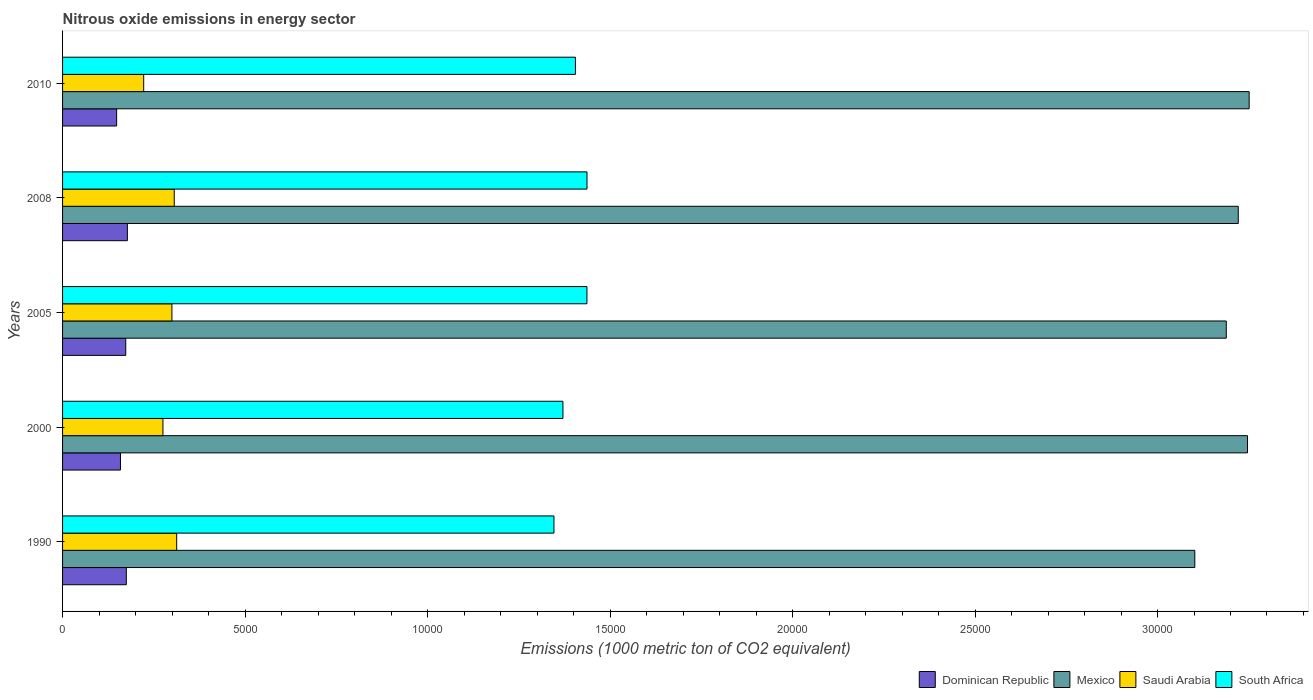How many different coloured bars are there?
Your response must be concise. 4. Are the number of bars on each tick of the Y-axis equal?
Your answer should be compact. Yes. How many bars are there on the 2nd tick from the top?
Offer a terse response. 4. How many bars are there on the 2nd tick from the bottom?
Provide a short and direct response. 4. What is the label of the 5th group of bars from the top?
Offer a very short reply. 1990. In how many cases, is the number of bars for a given year not equal to the number of legend labels?
Provide a succinct answer. 0. What is the amount of nitrous oxide emitted in Saudi Arabia in 2005?
Your answer should be very brief. 2996.3. Across all years, what is the maximum amount of nitrous oxide emitted in Dominican Republic?
Offer a very short reply. 1775.7. Across all years, what is the minimum amount of nitrous oxide emitted in Dominican Republic?
Provide a short and direct response. 1481.5. What is the total amount of nitrous oxide emitted in Saudi Arabia in the graph?
Make the answer very short. 1.42e+04. What is the difference between the amount of nitrous oxide emitted in Mexico in 2000 and that in 2005?
Ensure brevity in your answer.  581.7. What is the difference between the amount of nitrous oxide emitted in Saudi Arabia in 2005 and the amount of nitrous oxide emitted in Dominican Republic in 2008?
Provide a short and direct response. 1220.6. What is the average amount of nitrous oxide emitted in Saudi Arabia per year?
Ensure brevity in your answer.  2831.16. In the year 2008, what is the difference between the amount of nitrous oxide emitted in South Africa and amount of nitrous oxide emitted in Saudi Arabia?
Ensure brevity in your answer.  1.13e+04. What is the ratio of the amount of nitrous oxide emitted in Mexico in 2008 to that in 2010?
Offer a very short reply. 0.99. Is the amount of nitrous oxide emitted in South Africa in 2000 less than that in 2005?
Ensure brevity in your answer.  Yes. What is the difference between the highest and the second highest amount of nitrous oxide emitted in Mexico?
Your response must be concise. 45.2. What is the difference between the highest and the lowest amount of nitrous oxide emitted in Dominican Republic?
Provide a succinct answer. 294.2. Is it the case that in every year, the sum of the amount of nitrous oxide emitted in South Africa and amount of nitrous oxide emitted in Saudi Arabia is greater than the sum of amount of nitrous oxide emitted in Dominican Republic and amount of nitrous oxide emitted in Mexico?
Give a very brief answer. Yes. What does the 2nd bar from the top in 2005 represents?
Offer a very short reply. Saudi Arabia. What does the 3rd bar from the bottom in 2008 represents?
Offer a terse response. Saudi Arabia. How many years are there in the graph?
Ensure brevity in your answer.  5. What is the difference between two consecutive major ticks on the X-axis?
Make the answer very short. 5000. Are the values on the major ticks of X-axis written in scientific E-notation?
Provide a short and direct response. No. Does the graph contain any zero values?
Make the answer very short. No. Does the graph contain grids?
Make the answer very short. No. Where does the legend appear in the graph?
Offer a terse response. Bottom right. How are the legend labels stacked?
Provide a short and direct response. Horizontal. What is the title of the graph?
Your response must be concise. Nitrous oxide emissions in energy sector. Does "Yemen, Rep." appear as one of the legend labels in the graph?
Provide a short and direct response. No. What is the label or title of the X-axis?
Offer a very short reply. Emissions (1000 metric ton of CO2 equivalent). What is the Emissions (1000 metric ton of CO2 equivalent) of Dominican Republic in 1990?
Keep it short and to the point. 1746.5. What is the Emissions (1000 metric ton of CO2 equivalent) in Mexico in 1990?
Your response must be concise. 3.10e+04. What is the Emissions (1000 metric ton of CO2 equivalent) of Saudi Arabia in 1990?
Your response must be concise. 3126.9. What is the Emissions (1000 metric ton of CO2 equivalent) in South Africa in 1990?
Your response must be concise. 1.35e+04. What is the Emissions (1000 metric ton of CO2 equivalent) in Dominican Republic in 2000?
Ensure brevity in your answer.  1586.4. What is the Emissions (1000 metric ton of CO2 equivalent) of Mexico in 2000?
Provide a short and direct response. 3.25e+04. What is the Emissions (1000 metric ton of CO2 equivalent) in Saudi Arabia in 2000?
Your answer should be very brief. 2750.6. What is the Emissions (1000 metric ton of CO2 equivalent) in South Africa in 2000?
Give a very brief answer. 1.37e+04. What is the Emissions (1000 metric ton of CO2 equivalent) in Dominican Republic in 2005?
Offer a terse response. 1731. What is the Emissions (1000 metric ton of CO2 equivalent) in Mexico in 2005?
Provide a short and direct response. 3.19e+04. What is the Emissions (1000 metric ton of CO2 equivalent) in Saudi Arabia in 2005?
Provide a succinct answer. 2996.3. What is the Emissions (1000 metric ton of CO2 equivalent) of South Africa in 2005?
Give a very brief answer. 1.44e+04. What is the Emissions (1000 metric ton of CO2 equivalent) in Dominican Republic in 2008?
Offer a terse response. 1775.7. What is the Emissions (1000 metric ton of CO2 equivalent) of Mexico in 2008?
Your answer should be compact. 3.22e+04. What is the Emissions (1000 metric ton of CO2 equivalent) in Saudi Arabia in 2008?
Offer a terse response. 3059.4. What is the Emissions (1000 metric ton of CO2 equivalent) in South Africa in 2008?
Provide a short and direct response. 1.44e+04. What is the Emissions (1000 metric ton of CO2 equivalent) of Dominican Republic in 2010?
Your response must be concise. 1481.5. What is the Emissions (1000 metric ton of CO2 equivalent) in Mexico in 2010?
Offer a very short reply. 3.25e+04. What is the Emissions (1000 metric ton of CO2 equivalent) of Saudi Arabia in 2010?
Offer a very short reply. 2222.6. What is the Emissions (1000 metric ton of CO2 equivalent) in South Africa in 2010?
Offer a terse response. 1.41e+04. Across all years, what is the maximum Emissions (1000 metric ton of CO2 equivalent) of Dominican Republic?
Your answer should be compact. 1775.7. Across all years, what is the maximum Emissions (1000 metric ton of CO2 equivalent) of Mexico?
Your response must be concise. 3.25e+04. Across all years, what is the maximum Emissions (1000 metric ton of CO2 equivalent) of Saudi Arabia?
Give a very brief answer. 3126.9. Across all years, what is the maximum Emissions (1000 metric ton of CO2 equivalent) in South Africa?
Keep it short and to the point. 1.44e+04. Across all years, what is the minimum Emissions (1000 metric ton of CO2 equivalent) in Dominican Republic?
Give a very brief answer. 1481.5. Across all years, what is the minimum Emissions (1000 metric ton of CO2 equivalent) in Mexico?
Give a very brief answer. 3.10e+04. Across all years, what is the minimum Emissions (1000 metric ton of CO2 equivalent) of Saudi Arabia?
Offer a terse response. 2222.6. Across all years, what is the minimum Emissions (1000 metric ton of CO2 equivalent) of South Africa?
Keep it short and to the point. 1.35e+04. What is the total Emissions (1000 metric ton of CO2 equivalent) in Dominican Republic in the graph?
Keep it short and to the point. 8321.1. What is the total Emissions (1000 metric ton of CO2 equivalent) in Mexico in the graph?
Ensure brevity in your answer.  1.60e+05. What is the total Emissions (1000 metric ton of CO2 equivalent) in Saudi Arabia in the graph?
Provide a succinct answer. 1.42e+04. What is the total Emissions (1000 metric ton of CO2 equivalent) in South Africa in the graph?
Ensure brevity in your answer.  7.00e+04. What is the difference between the Emissions (1000 metric ton of CO2 equivalent) in Dominican Republic in 1990 and that in 2000?
Ensure brevity in your answer.  160.1. What is the difference between the Emissions (1000 metric ton of CO2 equivalent) of Mexico in 1990 and that in 2000?
Provide a short and direct response. -1444. What is the difference between the Emissions (1000 metric ton of CO2 equivalent) in Saudi Arabia in 1990 and that in 2000?
Make the answer very short. 376.3. What is the difference between the Emissions (1000 metric ton of CO2 equivalent) in South Africa in 1990 and that in 2000?
Give a very brief answer. -246.5. What is the difference between the Emissions (1000 metric ton of CO2 equivalent) in Mexico in 1990 and that in 2005?
Keep it short and to the point. -862.3. What is the difference between the Emissions (1000 metric ton of CO2 equivalent) in Saudi Arabia in 1990 and that in 2005?
Give a very brief answer. 130.6. What is the difference between the Emissions (1000 metric ton of CO2 equivalent) in South Africa in 1990 and that in 2005?
Provide a succinct answer. -903.7. What is the difference between the Emissions (1000 metric ton of CO2 equivalent) of Dominican Republic in 1990 and that in 2008?
Offer a very short reply. -29.2. What is the difference between the Emissions (1000 metric ton of CO2 equivalent) of Mexico in 1990 and that in 2008?
Make the answer very short. -1190.5. What is the difference between the Emissions (1000 metric ton of CO2 equivalent) in Saudi Arabia in 1990 and that in 2008?
Offer a terse response. 67.5. What is the difference between the Emissions (1000 metric ton of CO2 equivalent) in South Africa in 1990 and that in 2008?
Your answer should be compact. -905.7. What is the difference between the Emissions (1000 metric ton of CO2 equivalent) in Dominican Republic in 1990 and that in 2010?
Your answer should be compact. 265. What is the difference between the Emissions (1000 metric ton of CO2 equivalent) of Mexico in 1990 and that in 2010?
Your answer should be compact. -1489.2. What is the difference between the Emissions (1000 metric ton of CO2 equivalent) of Saudi Arabia in 1990 and that in 2010?
Offer a very short reply. 904.3. What is the difference between the Emissions (1000 metric ton of CO2 equivalent) in South Africa in 1990 and that in 2010?
Offer a very short reply. -588.2. What is the difference between the Emissions (1000 metric ton of CO2 equivalent) of Dominican Republic in 2000 and that in 2005?
Provide a short and direct response. -144.6. What is the difference between the Emissions (1000 metric ton of CO2 equivalent) of Mexico in 2000 and that in 2005?
Give a very brief answer. 581.7. What is the difference between the Emissions (1000 metric ton of CO2 equivalent) of Saudi Arabia in 2000 and that in 2005?
Offer a terse response. -245.7. What is the difference between the Emissions (1000 metric ton of CO2 equivalent) of South Africa in 2000 and that in 2005?
Your answer should be compact. -657.2. What is the difference between the Emissions (1000 metric ton of CO2 equivalent) in Dominican Republic in 2000 and that in 2008?
Give a very brief answer. -189.3. What is the difference between the Emissions (1000 metric ton of CO2 equivalent) in Mexico in 2000 and that in 2008?
Ensure brevity in your answer.  253.5. What is the difference between the Emissions (1000 metric ton of CO2 equivalent) of Saudi Arabia in 2000 and that in 2008?
Provide a short and direct response. -308.8. What is the difference between the Emissions (1000 metric ton of CO2 equivalent) of South Africa in 2000 and that in 2008?
Keep it short and to the point. -659.2. What is the difference between the Emissions (1000 metric ton of CO2 equivalent) in Dominican Republic in 2000 and that in 2010?
Provide a short and direct response. 104.9. What is the difference between the Emissions (1000 metric ton of CO2 equivalent) of Mexico in 2000 and that in 2010?
Provide a short and direct response. -45.2. What is the difference between the Emissions (1000 metric ton of CO2 equivalent) of Saudi Arabia in 2000 and that in 2010?
Make the answer very short. 528. What is the difference between the Emissions (1000 metric ton of CO2 equivalent) of South Africa in 2000 and that in 2010?
Keep it short and to the point. -341.7. What is the difference between the Emissions (1000 metric ton of CO2 equivalent) of Dominican Republic in 2005 and that in 2008?
Offer a very short reply. -44.7. What is the difference between the Emissions (1000 metric ton of CO2 equivalent) in Mexico in 2005 and that in 2008?
Offer a terse response. -328.2. What is the difference between the Emissions (1000 metric ton of CO2 equivalent) in Saudi Arabia in 2005 and that in 2008?
Provide a succinct answer. -63.1. What is the difference between the Emissions (1000 metric ton of CO2 equivalent) of South Africa in 2005 and that in 2008?
Ensure brevity in your answer.  -2. What is the difference between the Emissions (1000 metric ton of CO2 equivalent) in Dominican Republic in 2005 and that in 2010?
Your answer should be very brief. 249.5. What is the difference between the Emissions (1000 metric ton of CO2 equivalent) in Mexico in 2005 and that in 2010?
Ensure brevity in your answer.  -626.9. What is the difference between the Emissions (1000 metric ton of CO2 equivalent) of Saudi Arabia in 2005 and that in 2010?
Your answer should be very brief. 773.7. What is the difference between the Emissions (1000 metric ton of CO2 equivalent) in South Africa in 2005 and that in 2010?
Make the answer very short. 315.5. What is the difference between the Emissions (1000 metric ton of CO2 equivalent) in Dominican Republic in 2008 and that in 2010?
Your answer should be compact. 294.2. What is the difference between the Emissions (1000 metric ton of CO2 equivalent) of Mexico in 2008 and that in 2010?
Provide a succinct answer. -298.7. What is the difference between the Emissions (1000 metric ton of CO2 equivalent) in Saudi Arabia in 2008 and that in 2010?
Your answer should be compact. 836.8. What is the difference between the Emissions (1000 metric ton of CO2 equivalent) in South Africa in 2008 and that in 2010?
Make the answer very short. 317.5. What is the difference between the Emissions (1000 metric ton of CO2 equivalent) of Dominican Republic in 1990 and the Emissions (1000 metric ton of CO2 equivalent) of Mexico in 2000?
Keep it short and to the point. -3.07e+04. What is the difference between the Emissions (1000 metric ton of CO2 equivalent) in Dominican Republic in 1990 and the Emissions (1000 metric ton of CO2 equivalent) in Saudi Arabia in 2000?
Your response must be concise. -1004.1. What is the difference between the Emissions (1000 metric ton of CO2 equivalent) of Dominican Republic in 1990 and the Emissions (1000 metric ton of CO2 equivalent) of South Africa in 2000?
Make the answer very short. -1.20e+04. What is the difference between the Emissions (1000 metric ton of CO2 equivalent) in Mexico in 1990 and the Emissions (1000 metric ton of CO2 equivalent) in Saudi Arabia in 2000?
Offer a very short reply. 2.83e+04. What is the difference between the Emissions (1000 metric ton of CO2 equivalent) of Mexico in 1990 and the Emissions (1000 metric ton of CO2 equivalent) of South Africa in 2000?
Ensure brevity in your answer.  1.73e+04. What is the difference between the Emissions (1000 metric ton of CO2 equivalent) of Saudi Arabia in 1990 and the Emissions (1000 metric ton of CO2 equivalent) of South Africa in 2000?
Offer a terse response. -1.06e+04. What is the difference between the Emissions (1000 metric ton of CO2 equivalent) of Dominican Republic in 1990 and the Emissions (1000 metric ton of CO2 equivalent) of Mexico in 2005?
Provide a succinct answer. -3.01e+04. What is the difference between the Emissions (1000 metric ton of CO2 equivalent) of Dominican Republic in 1990 and the Emissions (1000 metric ton of CO2 equivalent) of Saudi Arabia in 2005?
Your response must be concise. -1249.8. What is the difference between the Emissions (1000 metric ton of CO2 equivalent) in Dominican Republic in 1990 and the Emissions (1000 metric ton of CO2 equivalent) in South Africa in 2005?
Your answer should be very brief. -1.26e+04. What is the difference between the Emissions (1000 metric ton of CO2 equivalent) in Mexico in 1990 and the Emissions (1000 metric ton of CO2 equivalent) in Saudi Arabia in 2005?
Ensure brevity in your answer.  2.80e+04. What is the difference between the Emissions (1000 metric ton of CO2 equivalent) in Mexico in 1990 and the Emissions (1000 metric ton of CO2 equivalent) in South Africa in 2005?
Your answer should be very brief. 1.67e+04. What is the difference between the Emissions (1000 metric ton of CO2 equivalent) in Saudi Arabia in 1990 and the Emissions (1000 metric ton of CO2 equivalent) in South Africa in 2005?
Keep it short and to the point. -1.12e+04. What is the difference between the Emissions (1000 metric ton of CO2 equivalent) of Dominican Republic in 1990 and the Emissions (1000 metric ton of CO2 equivalent) of Mexico in 2008?
Offer a very short reply. -3.05e+04. What is the difference between the Emissions (1000 metric ton of CO2 equivalent) of Dominican Republic in 1990 and the Emissions (1000 metric ton of CO2 equivalent) of Saudi Arabia in 2008?
Your answer should be compact. -1312.9. What is the difference between the Emissions (1000 metric ton of CO2 equivalent) of Dominican Republic in 1990 and the Emissions (1000 metric ton of CO2 equivalent) of South Africa in 2008?
Ensure brevity in your answer.  -1.26e+04. What is the difference between the Emissions (1000 metric ton of CO2 equivalent) in Mexico in 1990 and the Emissions (1000 metric ton of CO2 equivalent) in Saudi Arabia in 2008?
Your answer should be very brief. 2.80e+04. What is the difference between the Emissions (1000 metric ton of CO2 equivalent) in Mexico in 1990 and the Emissions (1000 metric ton of CO2 equivalent) in South Africa in 2008?
Ensure brevity in your answer.  1.67e+04. What is the difference between the Emissions (1000 metric ton of CO2 equivalent) of Saudi Arabia in 1990 and the Emissions (1000 metric ton of CO2 equivalent) of South Africa in 2008?
Provide a short and direct response. -1.12e+04. What is the difference between the Emissions (1000 metric ton of CO2 equivalent) in Dominican Republic in 1990 and the Emissions (1000 metric ton of CO2 equivalent) in Mexico in 2010?
Give a very brief answer. -3.08e+04. What is the difference between the Emissions (1000 metric ton of CO2 equivalent) of Dominican Republic in 1990 and the Emissions (1000 metric ton of CO2 equivalent) of Saudi Arabia in 2010?
Your answer should be very brief. -476.1. What is the difference between the Emissions (1000 metric ton of CO2 equivalent) in Dominican Republic in 1990 and the Emissions (1000 metric ton of CO2 equivalent) in South Africa in 2010?
Your answer should be compact. -1.23e+04. What is the difference between the Emissions (1000 metric ton of CO2 equivalent) in Mexico in 1990 and the Emissions (1000 metric ton of CO2 equivalent) in Saudi Arabia in 2010?
Your answer should be very brief. 2.88e+04. What is the difference between the Emissions (1000 metric ton of CO2 equivalent) of Mexico in 1990 and the Emissions (1000 metric ton of CO2 equivalent) of South Africa in 2010?
Make the answer very short. 1.70e+04. What is the difference between the Emissions (1000 metric ton of CO2 equivalent) of Saudi Arabia in 1990 and the Emissions (1000 metric ton of CO2 equivalent) of South Africa in 2010?
Offer a terse response. -1.09e+04. What is the difference between the Emissions (1000 metric ton of CO2 equivalent) in Dominican Republic in 2000 and the Emissions (1000 metric ton of CO2 equivalent) in Mexico in 2005?
Your answer should be compact. -3.03e+04. What is the difference between the Emissions (1000 metric ton of CO2 equivalent) of Dominican Republic in 2000 and the Emissions (1000 metric ton of CO2 equivalent) of Saudi Arabia in 2005?
Keep it short and to the point. -1409.9. What is the difference between the Emissions (1000 metric ton of CO2 equivalent) in Dominican Republic in 2000 and the Emissions (1000 metric ton of CO2 equivalent) in South Africa in 2005?
Your answer should be compact. -1.28e+04. What is the difference between the Emissions (1000 metric ton of CO2 equivalent) of Mexico in 2000 and the Emissions (1000 metric ton of CO2 equivalent) of Saudi Arabia in 2005?
Make the answer very short. 2.95e+04. What is the difference between the Emissions (1000 metric ton of CO2 equivalent) in Mexico in 2000 and the Emissions (1000 metric ton of CO2 equivalent) in South Africa in 2005?
Ensure brevity in your answer.  1.81e+04. What is the difference between the Emissions (1000 metric ton of CO2 equivalent) in Saudi Arabia in 2000 and the Emissions (1000 metric ton of CO2 equivalent) in South Africa in 2005?
Keep it short and to the point. -1.16e+04. What is the difference between the Emissions (1000 metric ton of CO2 equivalent) in Dominican Republic in 2000 and the Emissions (1000 metric ton of CO2 equivalent) in Mexico in 2008?
Ensure brevity in your answer.  -3.06e+04. What is the difference between the Emissions (1000 metric ton of CO2 equivalent) in Dominican Republic in 2000 and the Emissions (1000 metric ton of CO2 equivalent) in Saudi Arabia in 2008?
Your response must be concise. -1473. What is the difference between the Emissions (1000 metric ton of CO2 equivalent) of Dominican Republic in 2000 and the Emissions (1000 metric ton of CO2 equivalent) of South Africa in 2008?
Provide a succinct answer. -1.28e+04. What is the difference between the Emissions (1000 metric ton of CO2 equivalent) in Mexico in 2000 and the Emissions (1000 metric ton of CO2 equivalent) in Saudi Arabia in 2008?
Make the answer very short. 2.94e+04. What is the difference between the Emissions (1000 metric ton of CO2 equivalent) of Mexico in 2000 and the Emissions (1000 metric ton of CO2 equivalent) of South Africa in 2008?
Your response must be concise. 1.81e+04. What is the difference between the Emissions (1000 metric ton of CO2 equivalent) of Saudi Arabia in 2000 and the Emissions (1000 metric ton of CO2 equivalent) of South Africa in 2008?
Give a very brief answer. -1.16e+04. What is the difference between the Emissions (1000 metric ton of CO2 equivalent) of Dominican Republic in 2000 and the Emissions (1000 metric ton of CO2 equivalent) of Mexico in 2010?
Ensure brevity in your answer.  -3.09e+04. What is the difference between the Emissions (1000 metric ton of CO2 equivalent) in Dominican Republic in 2000 and the Emissions (1000 metric ton of CO2 equivalent) in Saudi Arabia in 2010?
Keep it short and to the point. -636.2. What is the difference between the Emissions (1000 metric ton of CO2 equivalent) in Dominican Republic in 2000 and the Emissions (1000 metric ton of CO2 equivalent) in South Africa in 2010?
Offer a terse response. -1.25e+04. What is the difference between the Emissions (1000 metric ton of CO2 equivalent) in Mexico in 2000 and the Emissions (1000 metric ton of CO2 equivalent) in Saudi Arabia in 2010?
Give a very brief answer. 3.02e+04. What is the difference between the Emissions (1000 metric ton of CO2 equivalent) of Mexico in 2000 and the Emissions (1000 metric ton of CO2 equivalent) of South Africa in 2010?
Provide a succinct answer. 1.84e+04. What is the difference between the Emissions (1000 metric ton of CO2 equivalent) of Saudi Arabia in 2000 and the Emissions (1000 metric ton of CO2 equivalent) of South Africa in 2010?
Your response must be concise. -1.13e+04. What is the difference between the Emissions (1000 metric ton of CO2 equivalent) in Dominican Republic in 2005 and the Emissions (1000 metric ton of CO2 equivalent) in Mexico in 2008?
Your answer should be very brief. -3.05e+04. What is the difference between the Emissions (1000 metric ton of CO2 equivalent) of Dominican Republic in 2005 and the Emissions (1000 metric ton of CO2 equivalent) of Saudi Arabia in 2008?
Give a very brief answer. -1328.4. What is the difference between the Emissions (1000 metric ton of CO2 equivalent) in Dominican Republic in 2005 and the Emissions (1000 metric ton of CO2 equivalent) in South Africa in 2008?
Provide a succinct answer. -1.26e+04. What is the difference between the Emissions (1000 metric ton of CO2 equivalent) of Mexico in 2005 and the Emissions (1000 metric ton of CO2 equivalent) of Saudi Arabia in 2008?
Make the answer very short. 2.88e+04. What is the difference between the Emissions (1000 metric ton of CO2 equivalent) in Mexico in 2005 and the Emissions (1000 metric ton of CO2 equivalent) in South Africa in 2008?
Give a very brief answer. 1.75e+04. What is the difference between the Emissions (1000 metric ton of CO2 equivalent) of Saudi Arabia in 2005 and the Emissions (1000 metric ton of CO2 equivalent) of South Africa in 2008?
Your response must be concise. -1.14e+04. What is the difference between the Emissions (1000 metric ton of CO2 equivalent) in Dominican Republic in 2005 and the Emissions (1000 metric ton of CO2 equivalent) in Mexico in 2010?
Make the answer very short. -3.08e+04. What is the difference between the Emissions (1000 metric ton of CO2 equivalent) of Dominican Republic in 2005 and the Emissions (1000 metric ton of CO2 equivalent) of Saudi Arabia in 2010?
Offer a very short reply. -491.6. What is the difference between the Emissions (1000 metric ton of CO2 equivalent) in Dominican Republic in 2005 and the Emissions (1000 metric ton of CO2 equivalent) in South Africa in 2010?
Offer a terse response. -1.23e+04. What is the difference between the Emissions (1000 metric ton of CO2 equivalent) of Mexico in 2005 and the Emissions (1000 metric ton of CO2 equivalent) of Saudi Arabia in 2010?
Ensure brevity in your answer.  2.97e+04. What is the difference between the Emissions (1000 metric ton of CO2 equivalent) in Mexico in 2005 and the Emissions (1000 metric ton of CO2 equivalent) in South Africa in 2010?
Keep it short and to the point. 1.78e+04. What is the difference between the Emissions (1000 metric ton of CO2 equivalent) in Saudi Arabia in 2005 and the Emissions (1000 metric ton of CO2 equivalent) in South Africa in 2010?
Offer a terse response. -1.11e+04. What is the difference between the Emissions (1000 metric ton of CO2 equivalent) in Dominican Republic in 2008 and the Emissions (1000 metric ton of CO2 equivalent) in Mexico in 2010?
Give a very brief answer. -3.07e+04. What is the difference between the Emissions (1000 metric ton of CO2 equivalent) of Dominican Republic in 2008 and the Emissions (1000 metric ton of CO2 equivalent) of Saudi Arabia in 2010?
Provide a succinct answer. -446.9. What is the difference between the Emissions (1000 metric ton of CO2 equivalent) in Dominican Republic in 2008 and the Emissions (1000 metric ton of CO2 equivalent) in South Africa in 2010?
Your response must be concise. -1.23e+04. What is the difference between the Emissions (1000 metric ton of CO2 equivalent) in Mexico in 2008 and the Emissions (1000 metric ton of CO2 equivalent) in Saudi Arabia in 2010?
Offer a very short reply. 3.00e+04. What is the difference between the Emissions (1000 metric ton of CO2 equivalent) in Mexico in 2008 and the Emissions (1000 metric ton of CO2 equivalent) in South Africa in 2010?
Provide a succinct answer. 1.82e+04. What is the difference between the Emissions (1000 metric ton of CO2 equivalent) of Saudi Arabia in 2008 and the Emissions (1000 metric ton of CO2 equivalent) of South Africa in 2010?
Your response must be concise. -1.10e+04. What is the average Emissions (1000 metric ton of CO2 equivalent) of Dominican Republic per year?
Provide a short and direct response. 1664.22. What is the average Emissions (1000 metric ton of CO2 equivalent) in Mexico per year?
Offer a very short reply. 3.20e+04. What is the average Emissions (1000 metric ton of CO2 equivalent) of Saudi Arabia per year?
Your response must be concise. 2831.16. What is the average Emissions (1000 metric ton of CO2 equivalent) of South Africa per year?
Your answer should be very brief. 1.40e+04. In the year 1990, what is the difference between the Emissions (1000 metric ton of CO2 equivalent) of Dominican Republic and Emissions (1000 metric ton of CO2 equivalent) of Mexico?
Your answer should be very brief. -2.93e+04. In the year 1990, what is the difference between the Emissions (1000 metric ton of CO2 equivalent) of Dominican Republic and Emissions (1000 metric ton of CO2 equivalent) of Saudi Arabia?
Offer a very short reply. -1380.4. In the year 1990, what is the difference between the Emissions (1000 metric ton of CO2 equivalent) in Dominican Republic and Emissions (1000 metric ton of CO2 equivalent) in South Africa?
Offer a very short reply. -1.17e+04. In the year 1990, what is the difference between the Emissions (1000 metric ton of CO2 equivalent) in Mexico and Emissions (1000 metric ton of CO2 equivalent) in Saudi Arabia?
Ensure brevity in your answer.  2.79e+04. In the year 1990, what is the difference between the Emissions (1000 metric ton of CO2 equivalent) in Mexico and Emissions (1000 metric ton of CO2 equivalent) in South Africa?
Provide a succinct answer. 1.76e+04. In the year 1990, what is the difference between the Emissions (1000 metric ton of CO2 equivalent) in Saudi Arabia and Emissions (1000 metric ton of CO2 equivalent) in South Africa?
Make the answer very short. -1.03e+04. In the year 2000, what is the difference between the Emissions (1000 metric ton of CO2 equivalent) of Dominican Republic and Emissions (1000 metric ton of CO2 equivalent) of Mexico?
Provide a short and direct response. -3.09e+04. In the year 2000, what is the difference between the Emissions (1000 metric ton of CO2 equivalent) in Dominican Republic and Emissions (1000 metric ton of CO2 equivalent) in Saudi Arabia?
Your answer should be very brief. -1164.2. In the year 2000, what is the difference between the Emissions (1000 metric ton of CO2 equivalent) of Dominican Republic and Emissions (1000 metric ton of CO2 equivalent) of South Africa?
Make the answer very short. -1.21e+04. In the year 2000, what is the difference between the Emissions (1000 metric ton of CO2 equivalent) of Mexico and Emissions (1000 metric ton of CO2 equivalent) of Saudi Arabia?
Give a very brief answer. 2.97e+04. In the year 2000, what is the difference between the Emissions (1000 metric ton of CO2 equivalent) of Mexico and Emissions (1000 metric ton of CO2 equivalent) of South Africa?
Make the answer very short. 1.88e+04. In the year 2000, what is the difference between the Emissions (1000 metric ton of CO2 equivalent) of Saudi Arabia and Emissions (1000 metric ton of CO2 equivalent) of South Africa?
Make the answer very short. -1.10e+04. In the year 2005, what is the difference between the Emissions (1000 metric ton of CO2 equivalent) in Dominican Republic and Emissions (1000 metric ton of CO2 equivalent) in Mexico?
Provide a succinct answer. -3.02e+04. In the year 2005, what is the difference between the Emissions (1000 metric ton of CO2 equivalent) of Dominican Republic and Emissions (1000 metric ton of CO2 equivalent) of Saudi Arabia?
Your answer should be very brief. -1265.3. In the year 2005, what is the difference between the Emissions (1000 metric ton of CO2 equivalent) of Dominican Republic and Emissions (1000 metric ton of CO2 equivalent) of South Africa?
Your answer should be very brief. -1.26e+04. In the year 2005, what is the difference between the Emissions (1000 metric ton of CO2 equivalent) in Mexico and Emissions (1000 metric ton of CO2 equivalent) in Saudi Arabia?
Provide a short and direct response. 2.89e+04. In the year 2005, what is the difference between the Emissions (1000 metric ton of CO2 equivalent) in Mexico and Emissions (1000 metric ton of CO2 equivalent) in South Africa?
Keep it short and to the point. 1.75e+04. In the year 2005, what is the difference between the Emissions (1000 metric ton of CO2 equivalent) of Saudi Arabia and Emissions (1000 metric ton of CO2 equivalent) of South Africa?
Make the answer very short. -1.14e+04. In the year 2008, what is the difference between the Emissions (1000 metric ton of CO2 equivalent) in Dominican Republic and Emissions (1000 metric ton of CO2 equivalent) in Mexico?
Your response must be concise. -3.04e+04. In the year 2008, what is the difference between the Emissions (1000 metric ton of CO2 equivalent) in Dominican Republic and Emissions (1000 metric ton of CO2 equivalent) in Saudi Arabia?
Provide a short and direct response. -1283.7. In the year 2008, what is the difference between the Emissions (1000 metric ton of CO2 equivalent) of Dominican Republic and Emissions (1000 metric ton of CO2 equivalent) of South Africa?
Your answer should be compact. -1.26e+04. In the year 2008, what is the difference between the Emissions (1000 metric ton of CO2 equivalent) of Mexico and Emissions (1000 metric ton of CO2 equivalent) of Saudi Arabia?
Ensure brevity in your answer.  2.92e+04. In the year 2008, what is the difference between the Emissions (1000 metric ton of CO2 equivalent) of Mexico and Emissions (1000 metric ton of CO2 equivalent) of South Africa?
Your answer should be very brief. 1.78e+04. In the year 2008, what is the difference between the Emissions (1000 metric ton of CO2 equivalent) in Saudi Arabia and Emissions (1000 metric ton of CO2 equivalent) in South Africa?
Offer a terse response. -1.13e+04. In the year 2010, what is the difference between the Emissions (1000 metric ton of CO2 equivalent) of Dominican Republic and Emissions (1000 metric ton of CO2 equivalent) of Mexico?
Your response must be concise. -3.10e+04. In the year 2010, what is the difference between the Emissions (1000 metric ton of CO2 equivalent) of Dominican Republic and Emissions (1000 metric ton of CO2 equivalent) of Saudi Arabia?
Keep it short and to the point. -741.1. In the year 2010, what is the difference between the Emissions (1000 metric ton of CO2 equivalent) in Dominican Republic and Emissions (1000 metric ton of CO2 equivalent) in South Africa?
Make the answer very short. -1.26e+04. In the year 2010, what is the difference between the Emissions (1000 metric ton of CO2 equivalent) of Mexico and Emissions (1000 metric ton of CO2 equivalent) of Saudi Arabia?
Make the answer very short. 3.03e+04. In the year 2010, what is the difference between the Emissions (1000 metric ton of CO2 equivalent) in Mexico and Emissions (1000 metric ton of CO2 equivalent) in South Africa?
Offer a very short reply. 1.85e+04. In the year 2010, what is the difference between the Emissions (1000 metric ton of CO2 equivalent) in Saudi Arabia and Emissions (1000 metric ton of CO2 equivalent) in South Africa?
Make the answer very short. -1.18e+04. What is the ratio of the Emissions (1000 metric ton of CO2 equivalent) of Dominican Republic in 1990 to that in 2000?
Offer a very short reply. 1.1. What is the ratio of the Emissions (1000 metric ton of CO2 equivalent) of Mexico in 1990 to that in 2000?
Provide a short and direct response. 0.96. What is the ratio of the Emissions (1000 metric ton of CO2 equivalent) in Saudi Arabia in 1990 to that in 2000?
Give a very brief answer. 1.14. What is the ratio of the Emissions (1000 metric ton of CO2 equivalent) in Dominican Republic in 1990 to that in 2005?
Offer a terse response. 1.01. What is the ratio of the Emissions (1000 metric ton of CO2 equivalent) in Mexico in 1990 to that in 2005?
Provide a succinct answer. 0.97. What is the ratio of the Emissions (1000 metric ton of CO2 equivalent) in Saudi Arabia in 1990 to that in 2005?
Your answer should be very brief. 1.04. What is the ratio of the Emissions (1000 metric ton of CO2 equivalent) of South Africa in 1990 to that in 2005?
Offer a very short reply. 0.94. What is the ratio of the Emissions (1000 metric ton of CO2 equivalent) of Dominican Republic in 1990 to that in 2008?
Ensure brevity in your answer.  0.98. What is the ratio of the Emissions (1000 metric ton of CO2 equivalent) in Mexico in 1990 to that in 2008?
Provide a short and direct response. 0.96. What is the ratio of the Emissions (1000 metric ton of CO2 equivalent) of Saudi Arabia in 1990 to that in 2008?
Offer a terse response. 1.02. What is the ratio of the Emissions (1000 metric ton of CO2 equivalent) of South Africa in 1990 to that in 2008?
Offer a very short reply. 0.94. What is the ratio of the Emissions (1000 metric ton of CO2 equivalent) in Dominican Republic in 1990 to that in 2010?
Ensure brevity in your answer.  1.18. What is the ratio of the Emissions (1000 metric ton of CO2 equivalent) in Mexico in 1990 to that in 2010?
Offer a terse response. 0.95. What is the ratio of the Emissions (1000 metric ton of CO2 equivalent) of Saudi Arabia in 1990 to that in 2010?
Offer a very short reply. 1.41. What is the ratio of the Emissions (1000 metric ton of CO2 equivalent) in South Africa in 1990 to that in 2010?
Offer a very short reply. 0.96. What is the ratio of the Emissions (1000 metric ton of CO2 equivalent) in Dominican Republic in 2000 to that in 2005?
Offer a terse response. 0.92. What is the ratio of the Emissions (1000 metric ton of CO2 equivalent) of Mexico in 2000 to that in 2005?
Your answer should be compact. 1.02. What is the ratio of the Emissions (1000 metric ton of CO2 equivalent) in Saudi Arabia in 2000 to that in 2005?
Your answer should be very brief. 0.92. What is the ratio of the Emissions (1000 metric ton of CO2 equivalent) in South Africa in 2000 to that in 2005?
Offer a very short reply. 0.95. What is the ratio of the Emissions (1000 metric ton of CO2 equivalent) in Dominican Republic in 2000 to that in 2008?
Offer a very short reply. 0.89. What is the ratio of the Emissions (1000 metric ton of CO2 equivalent) in Mexico in 2000 to that in 2008?
Provide a succinct answer. 1.01. What is the ratio of the Emissions (1000 metric ton of CO2 equivalent) of Saudi Arabia in 2000 to that in 2008?
Your answer should be very brief. 0.9. What is the ratio of the Emissions (1000 metric ton of CO2 equivalent) in South Africa in 2000 to that in 2008?
Keep it short and to the point. 0.95. What is the ratio of the Emissions (1000 metric ton of CO2 equivalent) of Dominican Republic in 2000 to that in 2010?
Keep it short and to the point. 1.07. What is the ratio of the Emissions (1000 metric ton of CO2 equivalent) in Saudi Arabia in 2000 to that in 2010?
Your response must be concise. 1.24. What is the ratio of the Emissions (1000 metric ton of CO2 equivalent) in South Africa in 2000 to that in 2010?
Offer a terse response. 0.98. What is the ratio of the Emissions (1000 metric ton of CO2 equivalent) in Dominican Republic in 2005 to that in 2008?
Keep it short and to the point. 0.97. What is the ratio of the Emissions (1000 metric ton of CO2 equivalent) of Mexico in 2005 to that in 2008?
Provide a succinct answer. 0.99. What is the ratio of the Emissions (1000 metric ton of CO2 equivalent) in Saudi Arabia in 2005 to that in 2008?
Give a very brief answer. 0.98. What is the ratio of the Emissions (1000 metric ton of CO2 equivalent) of South Africa in 2005 to that in 2008?
Ensure brevity in your answer.  1. What is the ratio of the Emissions (1000 metric ton of CO2 equivalent) in Dominican Republic in 2005 to that in 2010?
Your answer should be very brief. 1.17. What is the ratio of the Emissions (1000 metric ton of CO2 equivalent) in Mexico in 2005 to that in 2010?
Your answer should be compact. 0.98. What is the ratio of the Emissions (1000 metric ton of CO2 equivalent) of Saudi Arabia in 2005 to that in 2010?
Give a very brief answer. 1.35. What is the ratio of the Emissions (1000 metric ton of CO2 equivalent) in South Africa in 2005 to that in 2010?
Offer a very short reply. 1.02. What is the ratio of the Emissions (1000 metric ton of CO2 equivalent) of Dominican Republic in 2008 to that in 2010?
Give a very brief answer. 1.2. What is the ratio of the Emissions (1000 metric ton of CO2 equivalent) in Saudi Arabia in 2008 to that in 2010?
Your answer should be compact. 1.38. What is the ratio of the Emissions (1000 metric ton of CO2 equivalent) of South Africa in 2008 to that in 2010?
Offer a terse response. 1.02. What is the difference between the highest and the second highest Emissions (1000 metric ton of CO2 equivalent) in Dominican Republic?
Offer a very short reply. 29.2. What is the difference between the highest and the second highest Emissions (1000 metric ton of CO2 equivalent) in Mexico?
Offer a very short reply. 45.2. What is the difference between the highest and the second highest Emissions (1000 metric ton of CO2 equivalent) of Saudi Arabia?
Make the answer very short. 67.5. What is the difference between the highest and the second highest Emissions (1000 metric ton of CO2 equivalent) of South Africa?
Provide a succinct answer. 2. What is the difference between the highest and the lowest Emissions (1000 metric ton of CO2 equivalent) of Dominican Republic?
Make the answer very short. 294.2. What is the difference between the highest and the lowest Emissions (1000 metric ton of CO2 equivalent) in Mexico?
Ensure brevity in your answer.  1489.2. What is the difference between the highest and the lowest Emissions (1000 metric ton of CO2 equivalent) in Saudi Arabia?
Your answer should be compact. 904.3. What is the difference between the highest and the lowest Emissions (1000 metric ton of CO2 equivalent) in South Africa?
Make the answer very short. 905.7. 